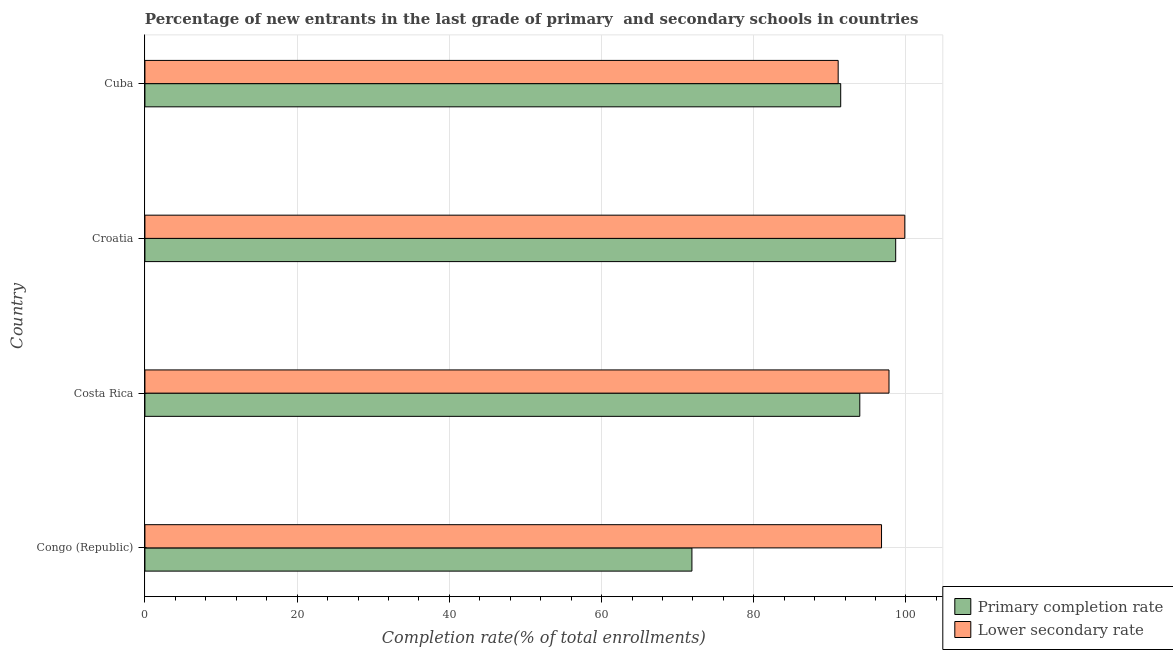How many different coloured bars are there?
Keep it short and to the point. 2. How many groups of bars are there?
Your answer should be compact. 4. Are the number of bars per tick equal to the number of legend labels?
Provide a succinct answer. Yes. Are the number of bars on each tick of the Y-axis equal?
Ensure brevity in your answer.  Yes. How many bars are there on the 2nd tick from the top?
Offer a terse response. 2. What is the label of the 1st group of bars from the top?
Make the answer very short. Cuba. In how many cases, is the number of bars for a given country not equal to the number of legend labels?
Offer a terse response. 0. What is the completion rate in primary schools in Croatia?
Offer a very short reply. 98.65. Across all countries, what is the maximum completion rate in primary schools?
Your answer should be very brief. 98.65. Across all countries, what is the minimum completion rate in secondary schools?
Keep it short and to the point. 91.09. In which country was the completion rate in primary schools maximum?
Your response must be concise. Croatia. In which country was the completion rate in secondary schools minimum?
Your response must be concise. Cuba. What is the total completion rate in secondary schools in the graph?
Make the answer very short. 385.49. What is the difference between the completion rate in primary schools in Congo (Republic) and that in Costa Rica?
Give a very brief answer. -22.06. What is the difference between the completion rate in primary schools in Costa Rica and the completion rate in secondary schools in Croatia?
Ensure brevity in your answer.  -5.91. What is the average completion rate in primary schools per country?
Offer a terse response. 88.97. What is the difference between the completion rate in secondary schools and completion rate in primary schools in Costa Rica?
Keep it short and to the point. 3.84. In how many countries, is the completion rate in primary schools greater than 76 %?
Your answer should be compact. 3. What is the ratio of the completion rate in primary schools in Croatia to that in Cuba?
Your answer should be very brief. 1.08. Is the difference between the completion rate in secondary schools in Congo (Republic) and Costa Rica greater than the difference between the completion rate in primary schools in Congo (Republic) and Costa Rica?
Provide a succinct answer. Yes. What is the difference between the highest and the second highest completion rate in secondary schools?
Your answer should be compact. 2.07. What is the difference between the highest and the lowest completion rate in secondary schools?
Offer a terse response. 8.75. What does the 1st bar from the top in Cuba represents?
Ensure brevity in your answer.  Lower secondary rate. What does the 2nd bar from the bottom in Costa Rica represents?
Provide a succinct answer. Lower secondary rate. Are all the bars in the graph horizontal?
Your answer should be very brief. Yes. How many countries are there in the graph?
Your answer should be compact. 4. Does the graph contain any zero values?
Offer a terse response. No. Where does the legend appear in the graph?
Give a very brief answer. Bottom right. What is the title of the graph?
Your answer should be compact. Percentage of new entrants in the last grade of primary  and secondary schools in countries. What is the label or title of the X-axis?
Keep it short and to the point. Completion rate(% of total enrollments). What is the label or title of the Y-axis?
Give a very brief answer. Country. What is the Completion rate(% of total enrollments) in Primary completion rate in Congo (Republic)?
Offer a very short reply. 71.87. What is the Completion rate(% of total enrollments) in Lower secondary rate in Congo (Republic)?
Offer a very short reply. 96.79. What is the Completion rate(% of total enrollments) of Primary completion rate in Costa Rica?
Ensure brevity in your answer.  93.93. What is the Completion rate(% of total enrollments) in Lower secondary rate in Costa Rica?
Ensure brevity in your answer.  97.77. What is the Completion rate(% of total enrollments) of Primary completion rate in Croatia?
Make the answer very short. 98.65. What is the Completion rate(% of total enrollments) of Lower secondary rate in Croatia?
Give a very brief answer. 99.84. What is the Completion rate(% of total enrollments) of Primary completion rate in Cuba?
Offer a terse response. 91.42. What is the Completion rate(% of total enrollments) of Lower secondary rate in Cuba?
Provide a short and direct response. 91.09. Across all countries, what is the maximum Completion rate(% of total enrollments) in Primary completion rate?
Provide a short and direct response. 98.65. Across all countries, what is the maximum Completion rate(% of total enrollments) in Lower secondary rate?
Your answer should be compact. 99.84. Across all countries, what is the minimum Completion rate(% of total enrollments) in Primary completion rate?
Your answer should be very brief. 71.87. Across all countries, what is the minimum Completion rate(% of total enrollments) in Lower secondary rate?
Your response must be concise. 91.09. What is the total Completion rate(% of total enrollments) in Primary completion rate in the graph?
Provide a succinct answer. 355.88. What is the total Completion rate(% of total enrollments) of Lower secondary rate in the graph?
Your answer should be compact. 385.49. What is the difference between the Completion rate(% of total enrollments) in Primary completion rate in Congo (Republic) and that in Costa Rica?
Your response must be concise. -22.06. What is the difference between the Completion rate(% of total enrollments) in Lower secondary rate in Congo (Republic) and that in Costa Rica?
Your answer should be compact. -0.98. What is the difference between the Completion rate(% of total enrollments) of Primary completion rate in Congo (Republic) and that in Croatia?
Offer a very short reply. -26.77. What is the difference between the Completion rate(% of total enrollments) of Lower secondary rate in Congo (Republic) and that in Croatia?
Keep it short and to the point. -3.06. What is the difference between the Completion rate(% of total enrollments) in Primary completion rate in Congo (Republic) and that in Cuba?
Ensure brevity in your answer.  -19.55. What is the difference between the Completion rate(% of total enrollments) of Lower secondary rate in Congo (Republic) and that in Cuba?
Keep it short and to the point. 5.7. What is the difference between the Completion rate(% of total enrollments) of Primary completion rate in Costa Rica and that in Croatia?
Your answer should be compact. -4.72. What is the difference between the Completion rate(% of total enrollments) of Lower secondary rate in Costa Rica and that in Croatia?
Offer a terse response. -2.07. What is the difference between the Completion rate(% of total enrollments) of Primary completion rate in Costa Rica and that in Cuba?
Keep it short and to the point. 2.51. What is the difference between the Completion rate(% of total enrollments) of Lower secondary rate in Costa Rica and that in Cuba?
Your response must be concise. 6.68. What is the difference between the Completion rate(% of total enrollments) in Primary completion rate in Croatia and that in Cuba?
Keep it short and to the point. 7.23. What is the difference between the Completion rate(% of total enrollments) in Lower secondary rate in Croatia and that in Cuba?
Your answer should be very brief. 8.75. What is the difference between the Completion rate(% of total enrollments) of Primary completion rate in Congo (Republic) and the Completion rate(% of total enrollments) of Lower secondary rate in Costa Rica?
Your answer should be very brief. -25.9. What is the difference between the Completion rate(% of total enrollments) of Primary completion rate in Congo (Republic) and the Completion rate(% of total enrollments) of Lower secondary rate in Croatia?
Your response must be concise. -27.97. What is the difference between the Completion rate(% of total enrollments) in Primary completion rate in Congo (Republic) and the Completion rate(% of total enrollments) in Lower secondary rate in Cuba?
Provide a short and direct response. -19.22. What is the difference between the Completion rate(% of total enrollments) of Primary completion rate in Costa Rica and the Completion rate(% of total enrollments) of Lower secondary rate in Croatia?
Make the answer very short. -5.91. What is the difference between the Completion rate(% of total enrollments) in Primary completion rate in Costa Rica and the Completion rate(% of total enrollments) in Lower secondary rate in Cuba?
Give a very brief answer. 2.84. What is the difference between the Completion rate(% of total enrollments) of Primary completion rate in Croatia and the Completion rate(% of total enrollments) of Lower secondary rate in Cuba?
Your response must be concise. 7.56. What is the average Completion rate(% of total enrollments) in Primary completion rate per country?
Keep it short and to the point. 88.97. What is the average Completion rate(% of total enrollments) of Lower secondary rate per country?
Ensure brevity in your answer.  96.37. What is the difference between the Completion rate(% of total enrollments) of Primary completion rate and Completion rate(% of total enrollments) of Lower secondary rate in Congo (Republic)?
Offer a terse response. -24.91. What is the difference between the Completion rate(% of total enrollments) of Primary completion rate and Completion rate(% of total enrollments) of Lower secondary rate in Costa Rica?
Keep it short and to the point. -3.84. What is the difference between the Completion rate(% of total enrollments) of Primary completion rate and Completion rate(% of total enrollments) of Lower secondary rate in Croatia?
Provide a short and direct response. -1.2. What is the difference between the Completion rate(% of total enrollments) in Primary completion rate and Completion rate(% of total enrollments) in Lower secondary rate in Cuba?
Keep it short and to the point. 0.33. What is the ratio of the Completion rate(% of total enrollments) in Primary completion rate in Congo (Republic) to that in Costa Rica?
Provide a short and direct response. 0.77. What is the ratio of the Completion rate(% of total enrollments) in Lower secondary rate in Congo (Republic) to that in Costa Rica?
Keep it short and to the point. 0.99. What is the ratio of the Completion rate(% of total enrollments) in Primary completion rate in Congo (Republic) to that in Croatia?
Offer a terse response. 0.73. What is the ratio of the Completion rate(% of total enrollments) in Lower secondary rate in Congo (Republic) to that in Croatia?
Your answer should be very brief. 0.97. What is the ratio of the Completion rate(% of total enrollments) of Primary completion rate in Congo (Republic) to that in Cuba?
Give a very brief answer. 0.79. What is the ratio of the Completion rate(% of total enrollments) in Primary completion rate in Costa Rica to that in Croatia?
Your response must be concise. 0.95. What is the ratio of the Completion rate(% of total enrollments) of Lower secondary rate in Costa Rica to that in Croatia?
Offer a very short reply. 0.98. What is the ratio of the Completion rate(% of total enrollments) of Primary completion rate in Costa Rica to that in Cuba?
Your response must be concise. 1.03. What is the ratio of the Completion rate(% of total enrollments) in Lower secondary rate in Costa Rica to that in Cuba?
Give a very brief answer. 1.07. What is the ratio of the Completion rate(% of total enrollments) of Primary completion rate in Croatia to that in Cuba?
Your answer should be very brief. 1.08. What is the ratio of the Completion rate(% of total enrollments) in Lower secondary rate in Croatia to that in Cuba?
Your response must be concise. 1.1. What is the difference between the highest and the second highest Completion rate(% of total enrollments) of Primary completion rate?
Your answer should be compact. 4.72. What is the difference between the highest and the second highest Completion rate(% of total enrollments) of Lower secondary rate?
Ensure brevity in your answer.  2.07. What is the difference between the highest and the lowest Completion rate(% of total enrollments) of Primary completion rate?
Your answer should be very brief. 26.77. What is the difference between the highest and the lowest Completion rate(% of total enrollments) of Lower secondary rate?
Your response must be concise. 8.75. 